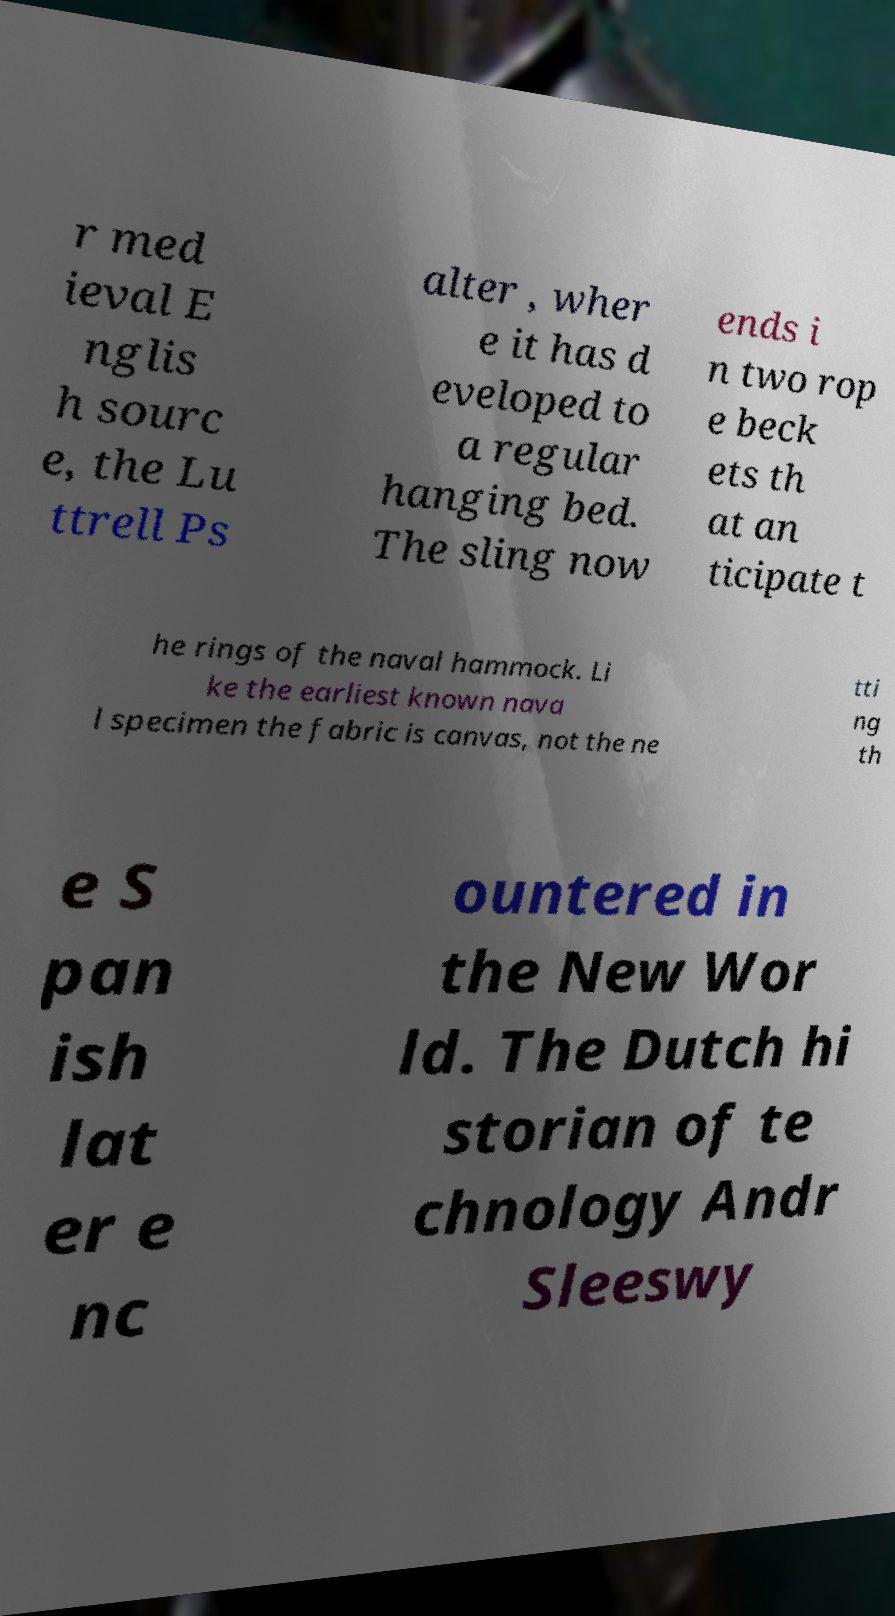Please identify and transcribe the text found in this image. r med ieval E nglis h sourc e, the Lu ttrell Ps alter , wher e it has d eveloped to a regular hanging bed. The sling now ends i n two rop e beck ets th at an ticipate t he rings of the naval hammock. Li ke the earliest known nava l specimen the fabric is canvas, not the ne tti ng th e S pan ish lat er e nc ountered in the New Wor ld. The Dutch hi storian of te chnology Andr Sleeswy 